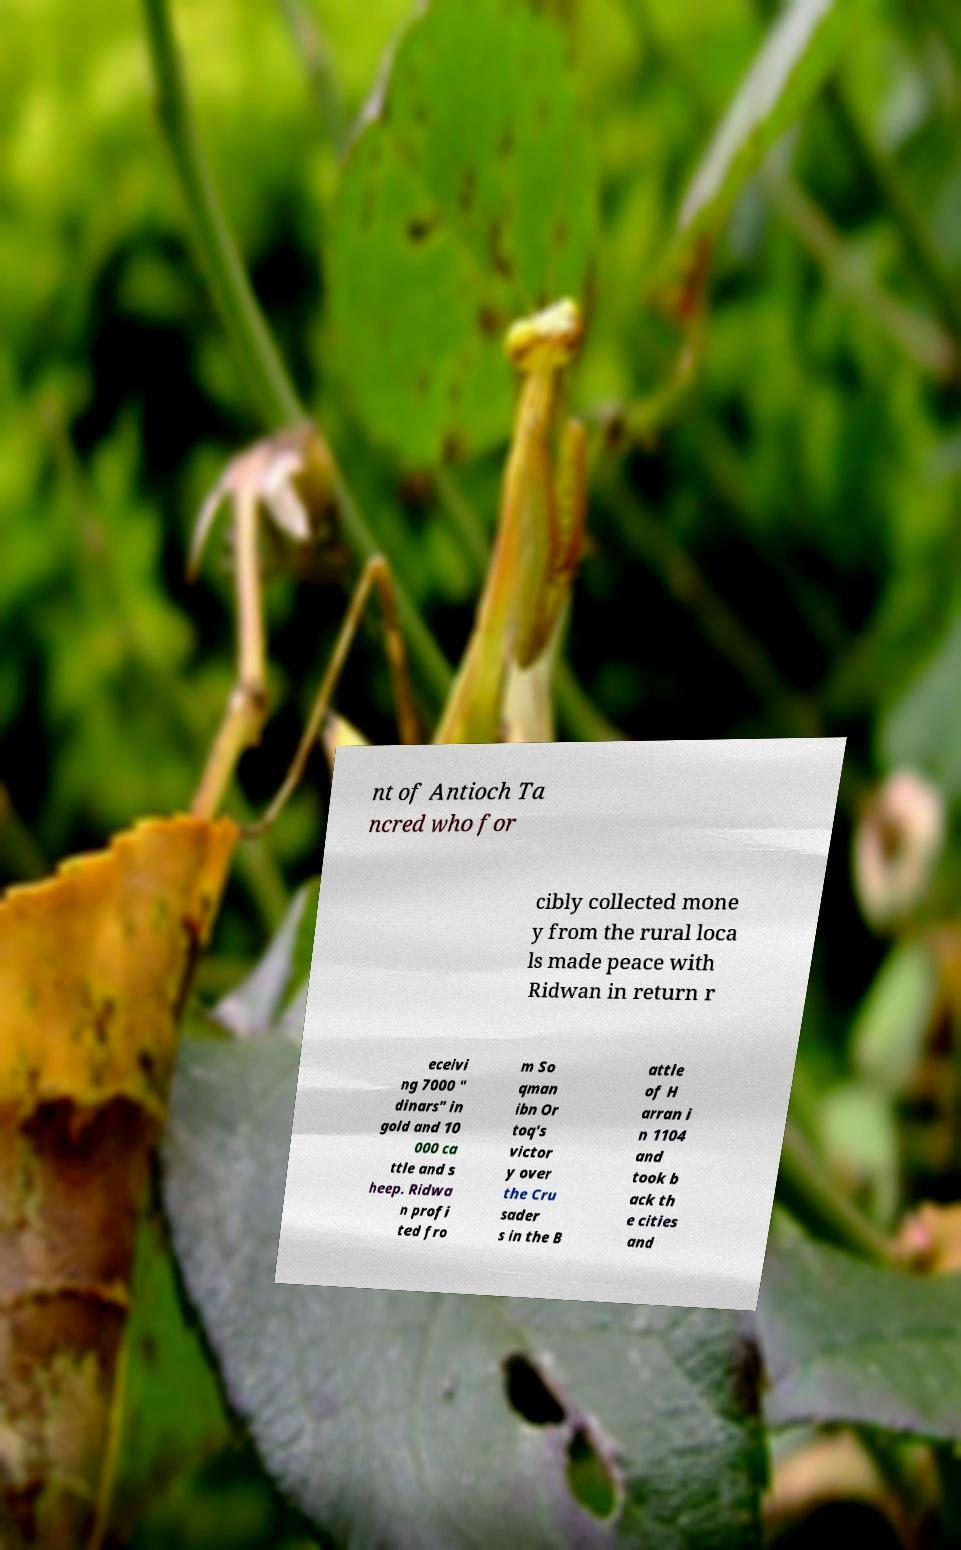Can you read and provide the text displayed in the image?This photo seems to have some interesting text. Can you extract and type it out for me? nt of Antioch Ta ncred who for cibly collected mone y from the rural loca ls made peace with Ridwan in return r eceivi ng 7000 " dinars" in gold and 10 000 ca ttle and s heep. Ridwa n profi ted fro m So qman ibn Or toq's victor y over the Cru sader s in the B attle of H arran i n 1104 and took b ack th e cities and 